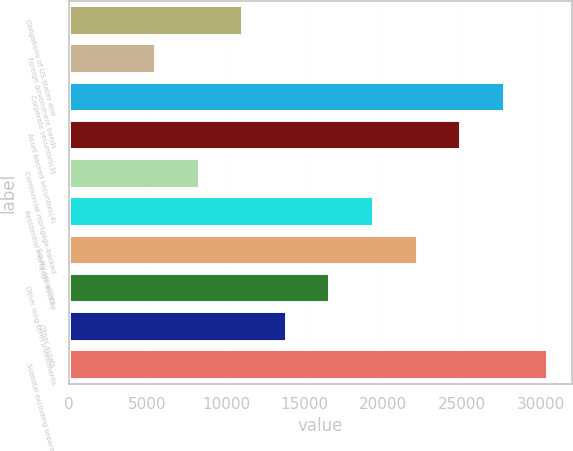<chart> <loc_0><loc_0><loc_500><loc_500><bar_chart><fcel>Obligations of US states and<fcel>Foreign government bonds<fcel>Corporate securities(3)<fcel>Asset-backed securities(4)<fcel>Commercial mortgage-backed<fcel>Residential mortgage-backed<fcel>Equity securities<fcel>Other long-term investments<fcel>Other assets<fcel>Subtotal excluding separate<nl><fcel>11087.6<fcel>5544.8<fcel>27716<fcel>24944.6<fcel>8316.2<fcel>19401.8<fcel>22173.2<fcel>16630.4<fcel>13859<fcel>30487.4<nl></chart> 